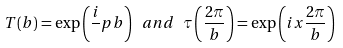<formula> <loc_0><loc_0><loc_500><loc_500>T ( b ) = \exp \left ( \frac { i } { } p b \right ) \ a n d \ \tau \left ( \frac { 2 \pi } { b } \right ) = \exp \left ( i x \frac { 2 \pi } { b } \right )</formula> 